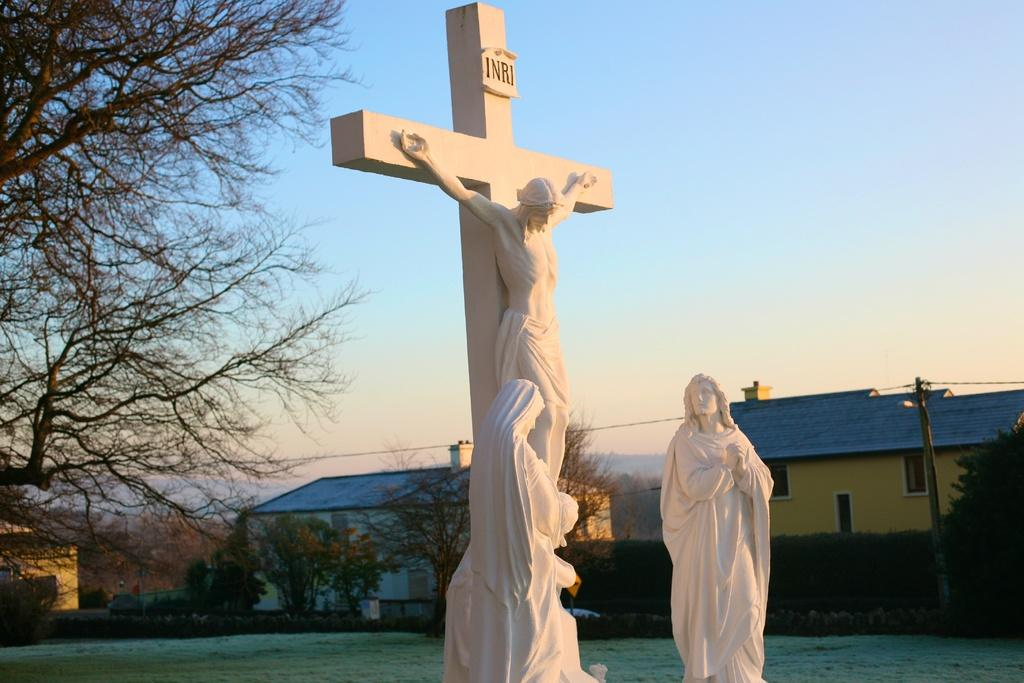<image>
Summarize the visual content of the image. A cross with Jesus nailed and INRI on the post. 